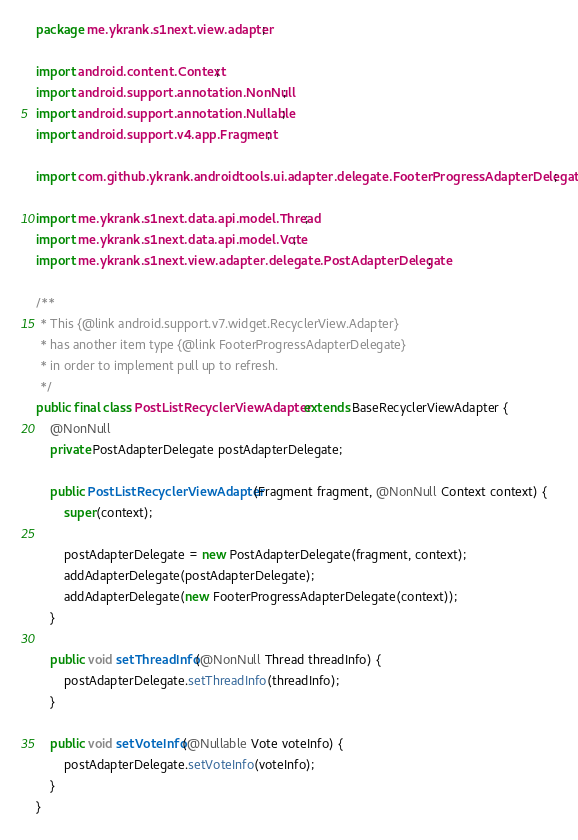Convert code to text. <code><loc_0><loc_0><loc_500><loc_500><_Java_>package me.ykrank.s1next.view.adapter;

import android.content.Context;
import android.support.annotation.NonNull;
import android.support.annotation.Nullable;
import android.support.v4.app.Fragment;

import com.github.ykrank.androidtools.ui.adapter.delegate.FooterProgressAdapterDelegate;

import me.ykrank.s1next.data.api.model.Thread;
import me.ykrank.s1next.data.api.model.Vote;
import me.ykrank.s1next.view.adapter.delegate.PostAdapterDelegate;

/**
 * This {@link android.support.v7.widget.RecyclerView.Adapter}
 * has another item type {@link FooterProgressAdapterDelegate}
 * in order to implement pull up to refresh.
 */
public final class PostListRecyclerViewAdapter extends BaseRecyclerViewAdapter {
    @NonNull
    private PostAdapterDelegate postAdapterDelegate;

    public PostListRecyclerViewAdapter(Fragment fragment, @NonNull Context context) {
        super(context);

        postAdapterDelegate = new PostAdapterDelegate(fragment, context);
        addAdapterDelegate(postAdapterDelegate);
        addAdapterDelegate(new FooterProgressAdapterDelegate(context));
    }

    public void setThreadInfo(@NonNull Thread threadInfo) {
        postAdapterDelegate.setThreadInfo(threadInfo);
    }

    public void setVoteInfo(@Nullable Vote voteInfo) {
        postAdapterDelegate.setVoteInfo(voteInfo);
    }
}
</code> 